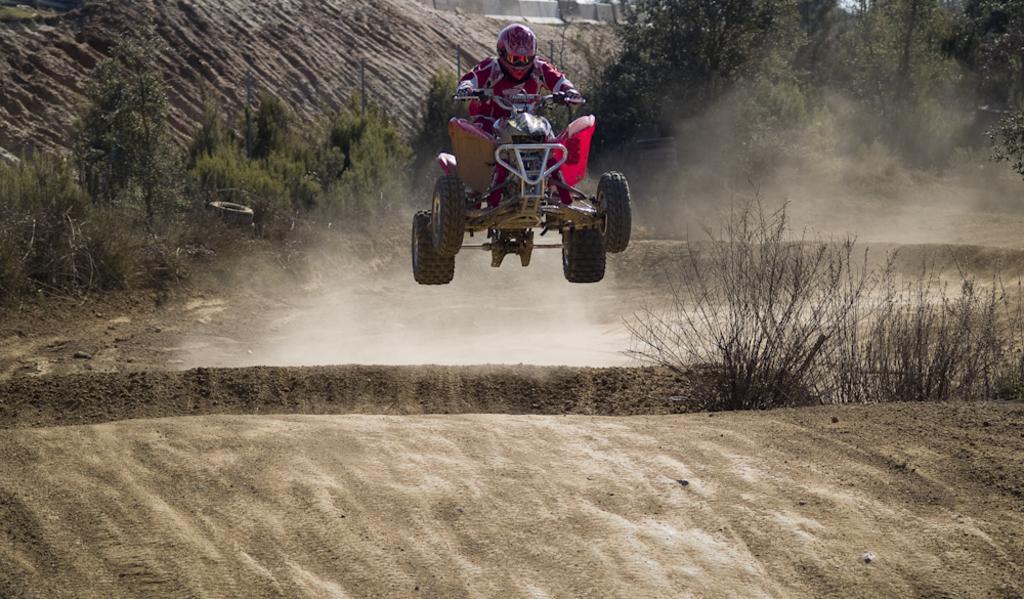Describe this image in one or two sentences. Here we can see a person riding a vehicle. This is ground. There are plants and trees. 